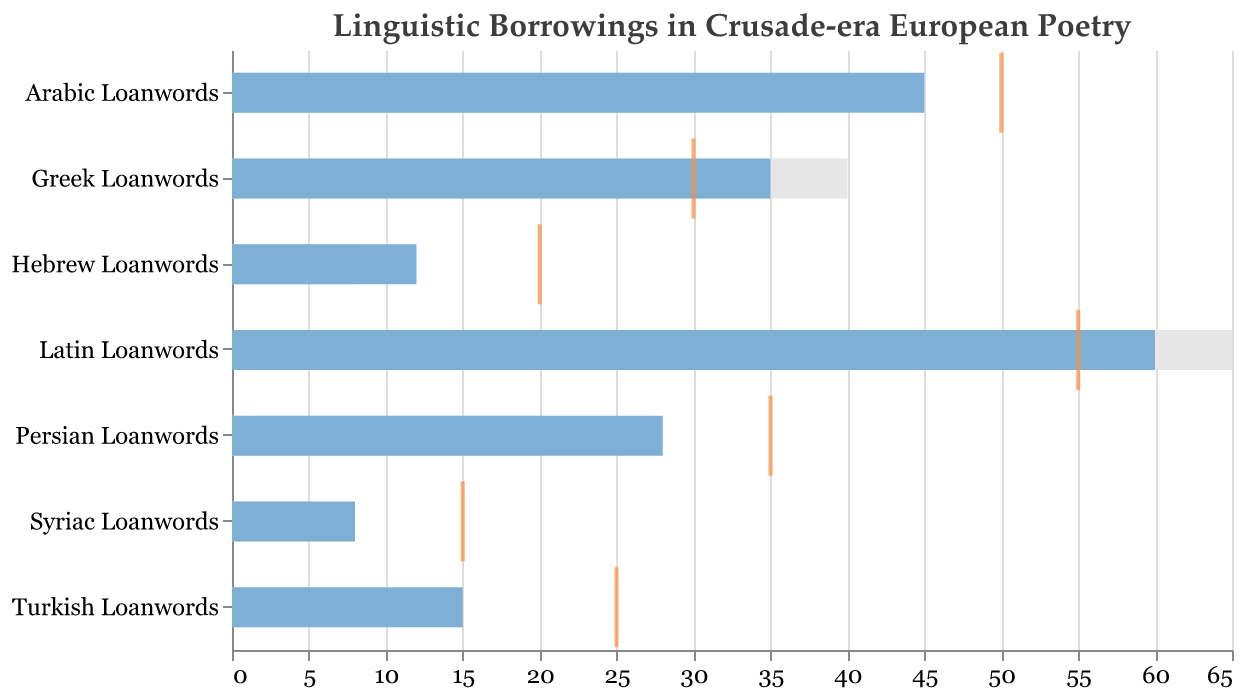What is the title of the figure? The title of the figure is given at the top and reads "Linguistic Borrowings in Crusade-era European Poetry".
Answer: Linguistic Borrowings in Crusade-era European Poetry What does the tick mark represent in the chart? The tick mark represents the target vocabulary growth for each linguistic category.
Answer: Target vocabulary growth Which category has the highest actual value? By comparing the actual values across categories, the category with the highest actual value is "Latin Loanwords" with 60.
Answer: Latin Loanwords Which category is closest to reaching its target? To determine which category is closest to its target, we look for the smallest difference between the actual and target values. The Arabic Loanwords category, with an actual value of 45 and a target of 50, has the smallest difference of 5.
Answer: Arabic Loanwords How many categories have an actual value higher than their comparative value? By examining the bars, we find that the categories whose actual values are higher than their comparative values are: Arabic Loanwords, Persian Loanwords, Turkish Loanwords, Hebrew Loanwords, Syriac Loanwords, and Greek Loanwords.
Answer: Six categories Which category does not meet its comparative value? By observing the figure, the category "Greek Loanwords" has an actual value of 35, which is less than its comparative value of 40.
Answer: Greek Loanwords By how much does the actual value of Latin Loanwords exceed its target value? The actual value of Latin Loanwords is 60, and the target value is 55, so the difference is 60 - 55 = 5.
Answer: 5 What's the total actual value for all categories combined? Sum the actual values: 45 (Arabic Loanwords) + 28 (Persian Loanwords) + 15 (Turkish Loanwords) + 12 (Hebrew Loanwords) + 8 (Syriac Loanwords) + 35 (Greek Loanwords) + 60 (Latin Loanwords) = 203.
Answer: 203 How does the number of Arabic Loanwords compare to the number of Greek Loanwords in the actual data? The actual number of Arabic Loanwords is 45 while the actual number of Greek Loanwords is 35. So, Arabic Loanwords exceed Greek Loanwords by 45 - 35 = 10.
Answer: 10 more Which category has the smallest difference between its actual and comparative value? To find the smallest difference, we calculate the absolute difference between actual and comparative values for each category. Arabic Loanwords: 45 - 30 = 15, Persian Loanwords: 28 - 20 = 8, Turkish Loanwords: 15 - 10 = 5, Hebrew Loanwords: 12 - 8 = 4, Syriac Loanwords: 8 - 5 = 3, Greek Loanwords: 35 - 40 = 5, Latin Loanwords: 60 - 65 = 5. The smallest difference is for Syriac Loanwords and is 3.
Answer: Syriac Loanwords 